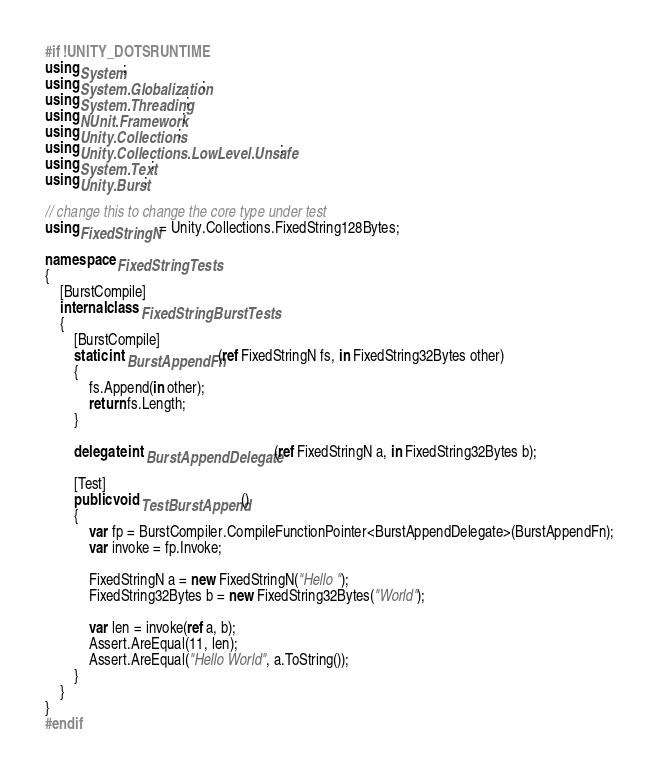Convert code to text. <code><loc_0><loc_0><loc_500><loc_500><_C#_>#if !UNITY_DOTSRUNTIME
using System;
using System.Globalization;
using System.Threading;
using NUnit.Framework;
using Unity.Collections;
using Unity.Collections.LowLevel.Unsafe;
using System.Text;
using Unity.Burst;

// change this to change the core type under test
using FixedStringN = Unity.Collections.FixedString128Bytes;

namespace FixedStringTests
{
    [BurstCompile]
    internal class FixedStringBurstTests
    {
        [BurstCompile]
        static int BurstAppendFn(ref FixedStringN fs, in FixedString32Bytes other)
        {
            fs.Append(in other);
            return fs.Length;
        }

        delegate int BurstAppendDelegate(ref FixedStringN a, in FixedString32Bytes b);

        [Test]
        public void TestBurstAppend()
        {
            var fp = BurstCompiler.CompileFunctionPointer<BurstAppendDelegate>(BurstAppendFn);
            var invoke = fp.Invoke;

            FixedStringN a = new FixedStringN("Hello ");
            FixedString32Bytes b = new FixedString32Bytes("World");

            var len = invoke(ref a, b);
            Assert.AreEqual(11, len);
            Assert.AreEqual("Hello World", a.ToString());
        }
    }
}
#endif
</code> 